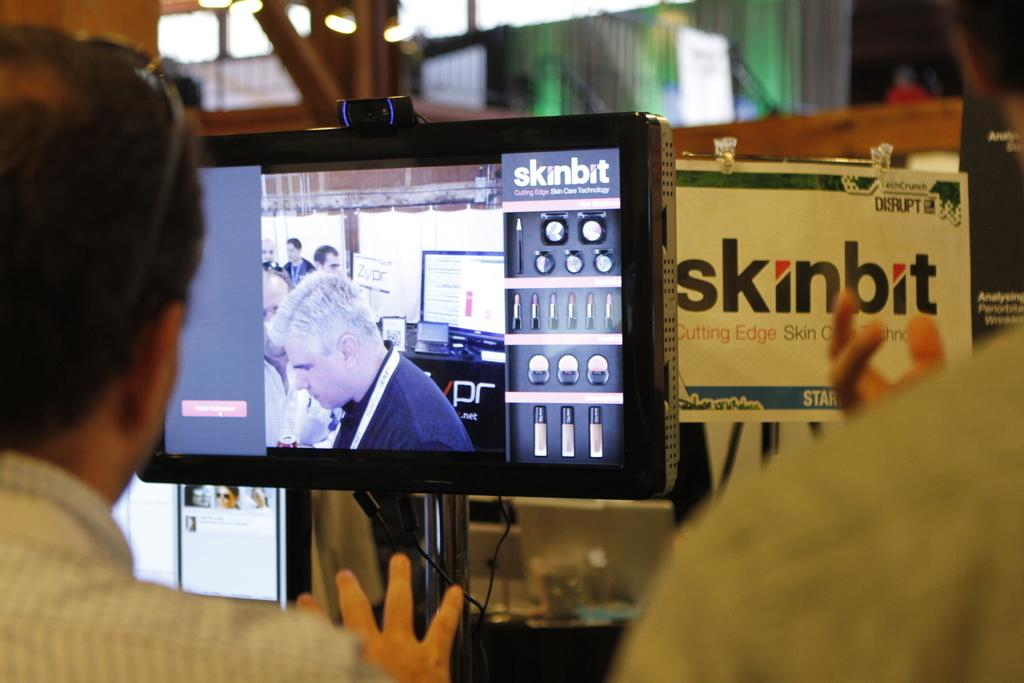<image>
Share a concise interpretation of the image provided. Several people are looking at a Skinbit display that includes a tv. 